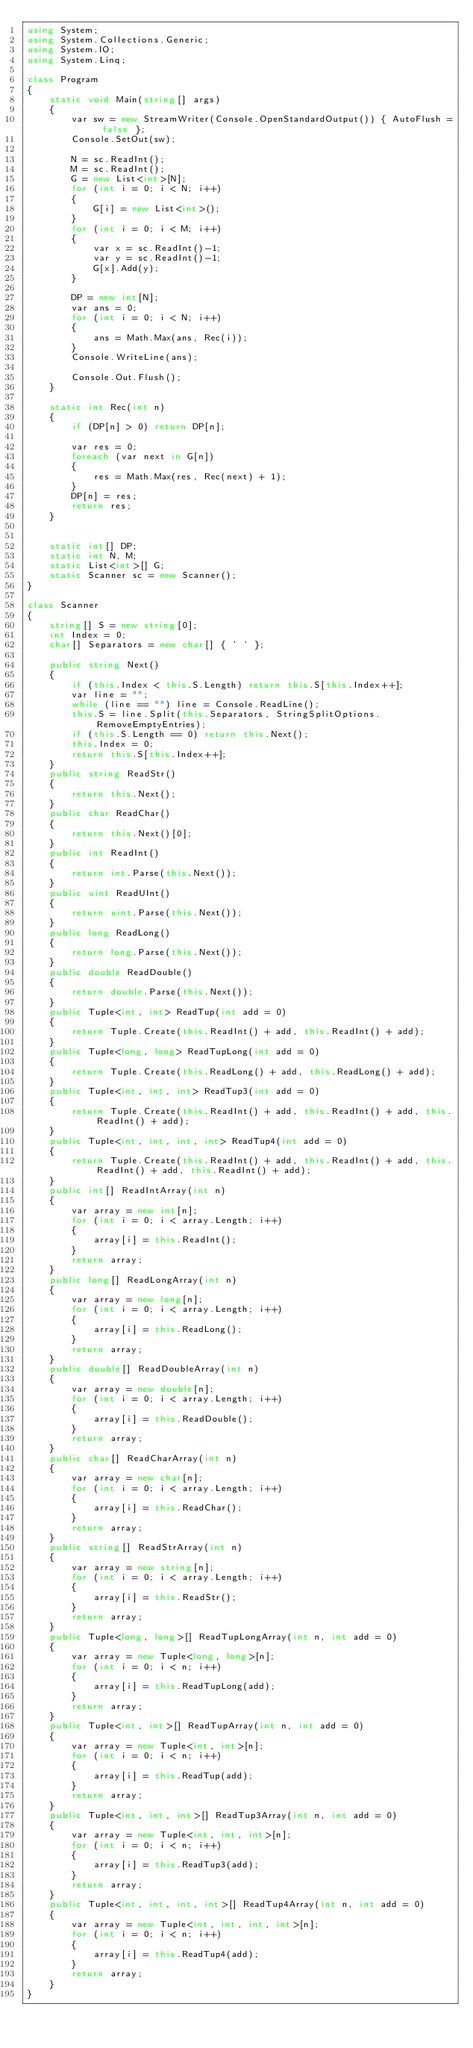Convert code to text. <code><loc_0><loc_0><loc_500><loc_500><_C#_>using System;
using System.Collections.Generic;
using System.IO;
using System.Linq;

class Program
{
    static void Main(string[] args)
    {
        var sw = new StreamWriter(Console.OpenStandardOutput()) { AutoFlush = false };
        Console.SetOut(sw);

        N = sc.ReadInt();
        M = sc.ReadInt();
        G = new List<int>[N];
        for (int i = 0; i < N; i++)
        {
            G[i] = new List<int>();
        }
        for (int i = 0; i < M; i++)
        {
            var x = sc.ReadInt()-1;
            var y = sc.ReadInt()-1;
            G[x].Add(y);
        }

        DP = new int[N];
        var ans = 0;
        for (int i = 0; i < N; i++)
        {
            ans = Math.Max(ans, Rec(i));
        }
        Console.WriteLine(ans);

        Console.Out.Flush();
    }

    static int Rec(int n)
    {
        if (DP[n] > 0) return DP[n];

        var res = 0;
        foreach (var next in G[n])
        {
            res = Math.Max(res, Rec(next) + 1);
        }
        DP[n] = res;
        return res;
    }


    static int[] DP;
    static int N, M;
    static List<int>[] G;
    static Scanner sc = new Scanner();
}

class Scanner
{
    string[] S = new string[0];
    int Index = 0;
    char[] Separators = new char[] { ' ' };

    public string Next()
    {
        if (this.Index < this.S.Length) return this.S[this.Index++];
        var line = "";
        while (line == "") line = Console.ReadLine();
        this.S = line.Split(this.Separators, StringSplitOptions.RemoveEmptyEntries);
        if (this.S.Length == 0) return this.Next();
        this.Index = 0;
        return this.S[this.Index++];
    }
    public string ReadStr()
    {
        return this.Next();
    }
    public char ReadChar()
    {
        return this.Next()[0];
    }
    public int ReadInt()
    {
        return int.Parse(this.Next());
    }
    public uint ReadUInt()
    {
        return uint.Parse(this.Next());
    }
    public long ReadLong()
    {
        return long.Parse(this.Next());
    }
    public double ReadDouble()
    {
        return double.Parse(this.Next());
    }
    public Tuple<int, int> ReadTup(int add = 0)
    {
        return Tuple.Create(this.ReadInt() + add, this.ReadInt() + add);
    }
    public Tuple<long, long> ReadTupLong(int add = 0)
    {
        return Tuple.Create(this.ReadLong() + add, this.ReadLong() + add);
    }
    public Tuple<int, int, int> ReadTup3(int add = 0)
    {
        return Tuple.Create(this.ReadInt() + add, this.ReadInt() + add, this.ReadInt() + add);
    }
    public Tuple<int, int, int, int> ReadTup4(int add = 0)
    {
        return Tuple.Create(this.ReadInt() + add, this.ReadInt() + add, this.ReadInt() + add, this.ReadInt() + add);
    }
    public int[] ReadIntArray(int n)
    {
        var array = new int[n];
        for (int i = 0; i < array.Length; i++)
        {
            array[i] = this.ReadInt();
        }
        return array;
    }
    public long[] ReadLongArray(int n)
    {
        var array = new long[n];
        for (int i = 0; i < array.Length; i++)
        {
            array[i] = this.ReadLong();
        }
        return array;
    }
    public double[] ReadDoubleArray(int n)
    {
        var array = new double[n];
        for (int i = 0; i < array.Length; i++)
        {
            array[i] = this.ReadDouble();
        }
        return array;
    }
    public char[] ReadCharArray(int n)
    {
        var array = new char[n];
        for (int i = 0; i < array.Length; i++)
        {
            array[i] = this.ReadChar();
        }
        return array;
    }
    public string[] ReadStrArray(int n)
    {
        var array = new string[n];
        for (int i = 0; i < array.Length; i++)
        {
            array[i] = this.ReadStr();
        }
        return array;
    }
    public Tuple<long, long>[] ReadTupLongArray(int n, int add = 0)
    {
        var array = new Tuple<long, long>[n];
        for (int i = 0; i < n; i++)
        {
            array[i] = this.ReadTupLong(add);
        }
        return array;
    }
    public Tuple<int, int>[] ReadTupArray(int n, int add = 0)
    {
        var array = new Tuple<int, int>[n];
        for (int i = 0; i < n; i++)
        {
            array[i] = this.ReadTup(add);
        }
        return array;
    }
    public Tuple<int, int, int>[] ReadTup3Array(int n, int add = 0)
    {
        var array = new Tuple<int, int, int>[n];
        for (int i = 0; i < n; i++)
        {
            array[i] = this.ReadTup3(add);
        }
        return array;
    }
    public Tuple<int, int, int, int>[] ReadTup4Array(int n, int add = 0)
    {
        var array = new Tuple<int, int, int, int>[n];
        for (int i = 0; i < n; i++)
        {
            array[i] = this.ReadTup4(add);
        }
        return array;
    }
}
</code> 